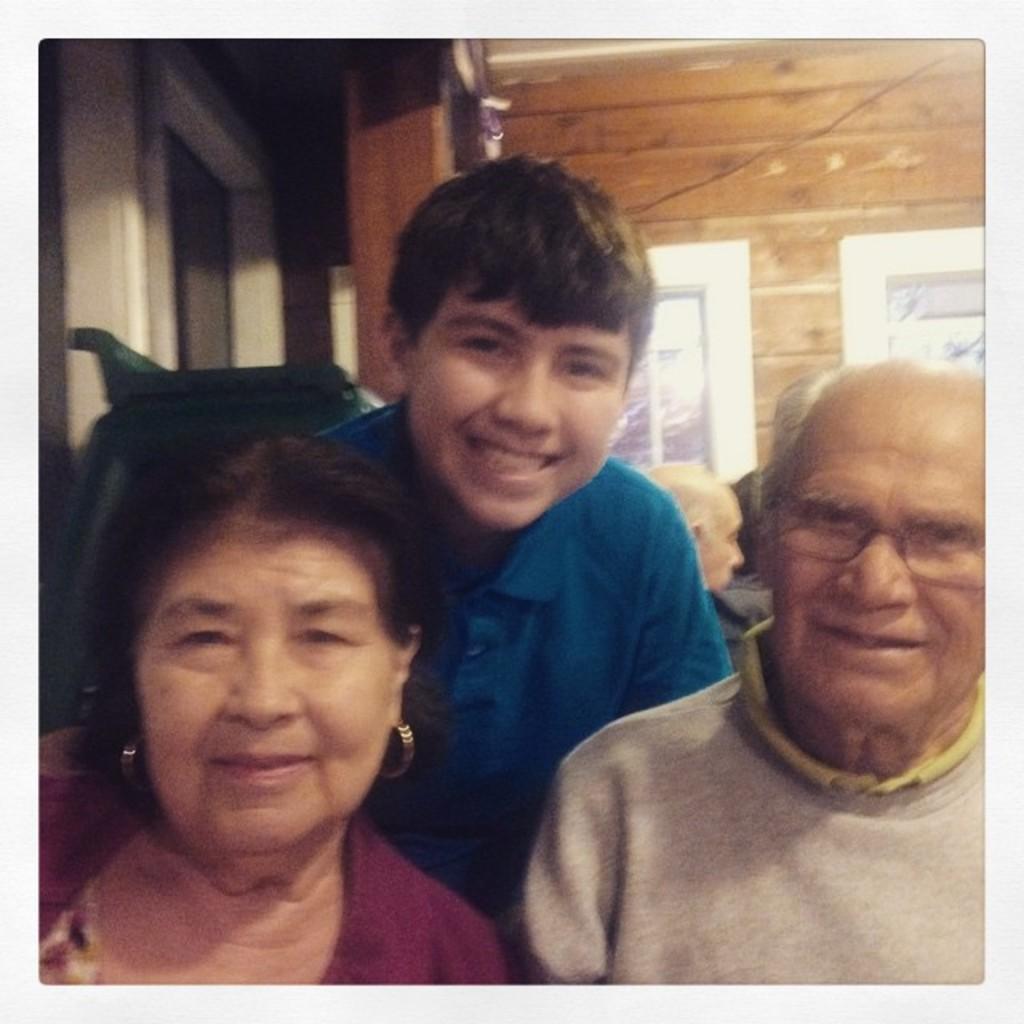Describe this image in one or two sentences. In this image we can see there are three people with a smile on their face, behind them there are other people. In the background there is a wall. 